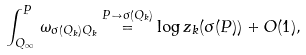Convert formula to latex. <formula><loc_0><loc_0><loc_500><loc_500>\int _ { Q _ { \infty } } ^ { P } \, \omega _ { \sigma ( Q _ { k } ) Q _ { k } } \stackrel { P \to \sigma ( Q _ { k } ) } { = } \log z _ { k } ( \sigma ( P ) ) + O ( 1 ) ,</formula> 